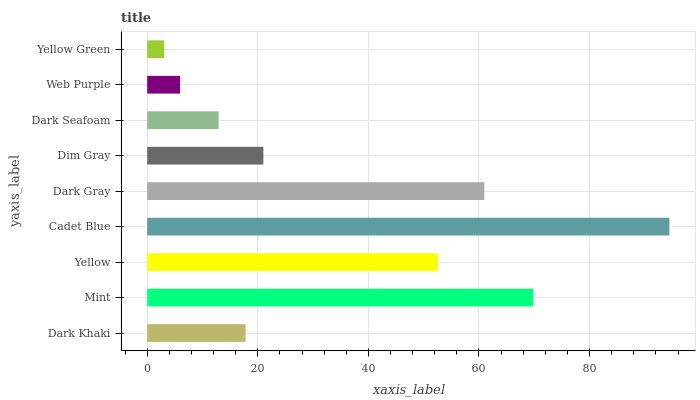Is Yellow Green the minimum?
Answer yes or no. Yes. Is Cadet Blue the maximum?
Answer yes or no. Yes. Is Mint the minimum?
Answer yes or no. No. Is Mint the maximum?
Answer yes or no. No. Is Mint greater than Dark Khaki?
Answer yes or no. Yes. Is Dark Khaki less than Mint?
Answer yes or no. Yes. Is Dark Khaki greater than Mint?
Answer yes or no. No. Is Mint less than Dark Khaki?
Answer yes or no. No. Is Dim Gray the high median?
Answer yes or no. Yes. Is Dim Gray the low median?
Answer yes or no. Yes. Is Dark Khaki the high median?
Answer yes or no. No. Is Web Purple the low median?
Answer yes or no. No. 